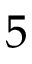<formula> <loc_0><loc_0><loc_500><loc_500>5</formula> 